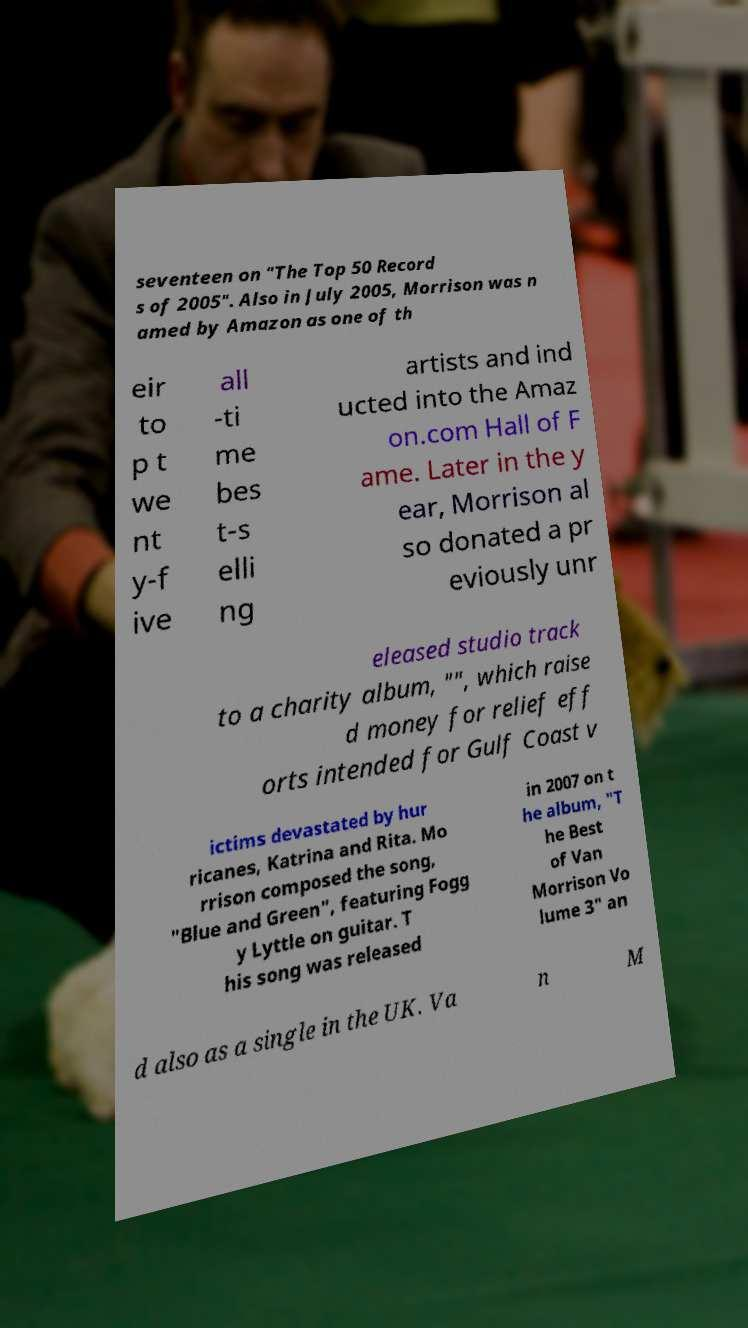Can you read and provide the text displayed in the image?This photo seems to have some interesting text. Can you extract and type it out for me? seventeen on "The Top 50 Record s of 2005". Also in July 2005, Morrison was n amed by Amazon as one of th eir to p t we nt y-f ive all -ti me bes t-s elli ng artists and ind ucted into the Amaz on.com Hall of F ame. Later in the y ear, Morrison al so donated a pr eviously unr eleased studio track to a charity album, "", which raise d money for relief eff orts intended for Gulf Coast v ictims devastated by hur ricanes, Katrina and Rita. Mo rrison composed the song, "Blue and Green", featuring Fogg y Lyttle on guitar. T his song was released in 2007 on t he album, "T he Best of Van Morrison Vo lume 3" an d also as a single in the UK. Va n M 